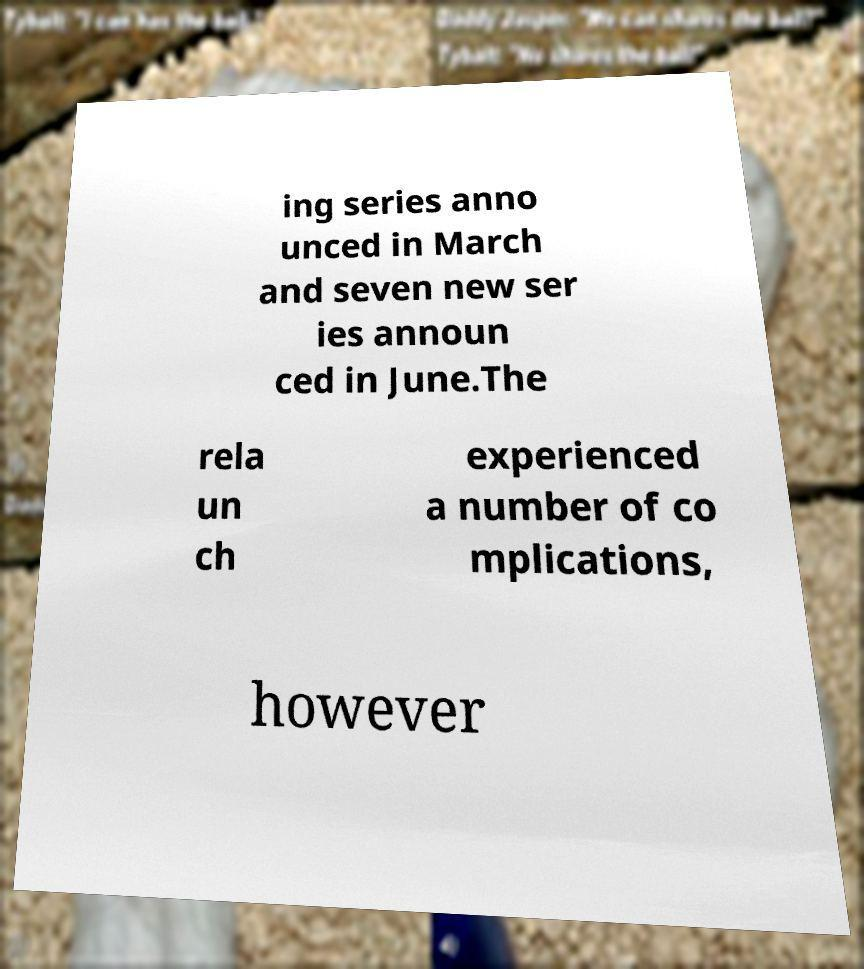There's text embedded in this image that I need extracted. Can you transcribe it verbatim? ing series anno unced in March and seven new ser ies announ ced in June.The rela un ch experienced a number of co mplications, however 